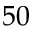Convert formula to latex. <formula><loc_0><loc_0><loc_500><loc_500>5 0</formula> 